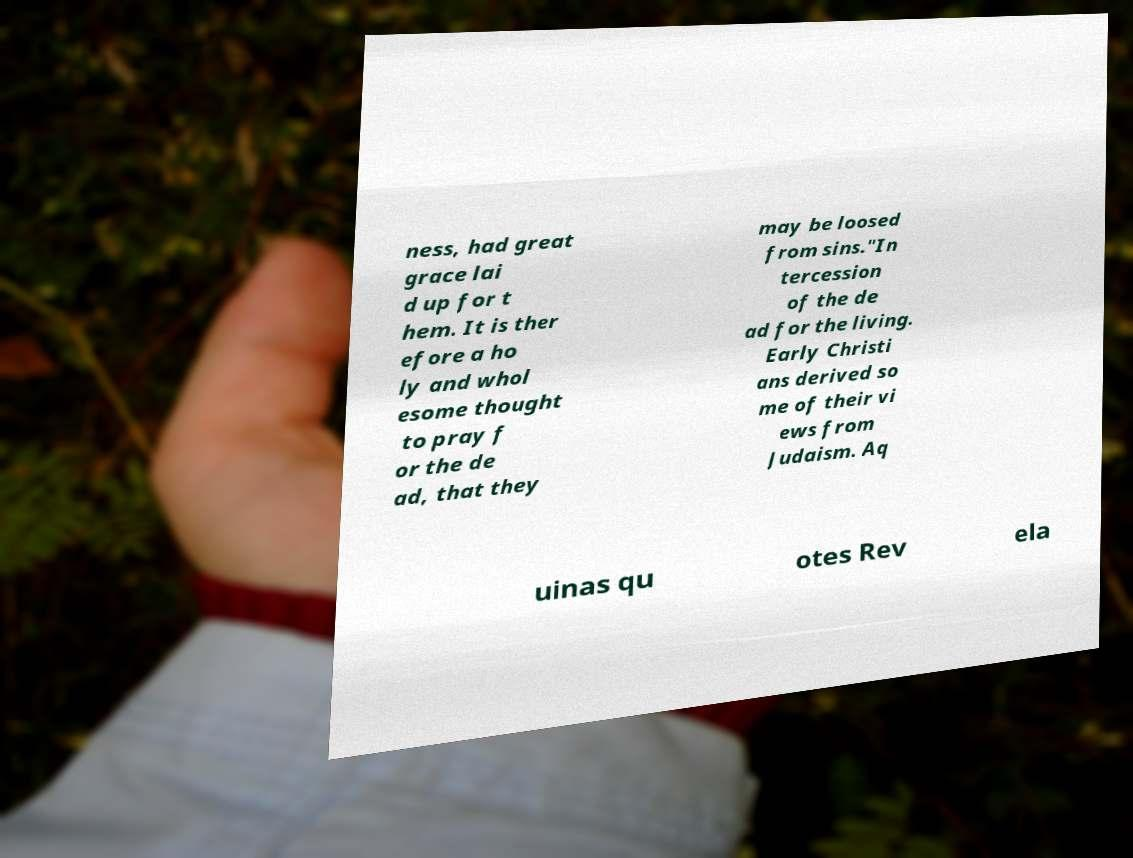For documentation purposes, I need the text within this image transcribed. Could you provide that? ness, had great grace lai d up for t hem. It is ther efore a ho ly and whol esome thought to pray f or the de ad, that they may be loosed from sins."In tercession of the de ad for the living. Early Christi ans derived so me of their vi ews from Judaism. Aq uinas qu otes Rev ela 